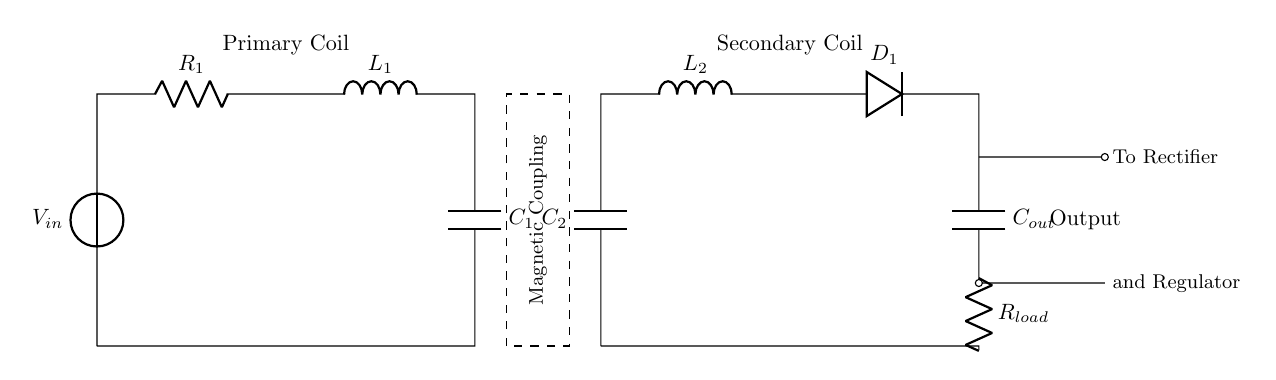What is the input voltage in the circuit? The input voltage is labeled as \( V_{in} \) at the voltage source on the primary side of the circuit.
Answer: \( V_{in} \) What component is responsible for magnetic coupling? The dashed rectangle labeled "Magnetic Coupling" represents the area where the primary and secondary coils interact, indicating the function of magnetic coupling.
Answer: Magnetic Coupling What happens to the output current? The output current flows through the components on the secondary side, specifically through the rectifier (D1) before reaching the load resistor (R_load).
Answer: Flows to R_load How many inductors are present in the circuit? Two inductors are indicated by the labels \( L_1 \) and \( L_2 \) on the primary and secondary sides, respectively.
Answer: Two What role does the capacitor \( C_1 \) play in the circuit? Capacitor \( C_1 \) is used for energy storage and smoothing the voltage in the primary circuit, ensuring stable operation of the inductive charging system.
Answer: Energy storage What is the function of the rectifier in this circuit? The rectifier, labeled as D1, converts the alternating current generated in the secondary coil into direct current, providing the correct form of power for R_load.
Answer: Converts AC to DC What does \( R_{load} \) represent? \( R_{load} \) represents the load resistor, which simulates the device or equipment that will receive power from the inductive charging system.
Answer: Load resistor 